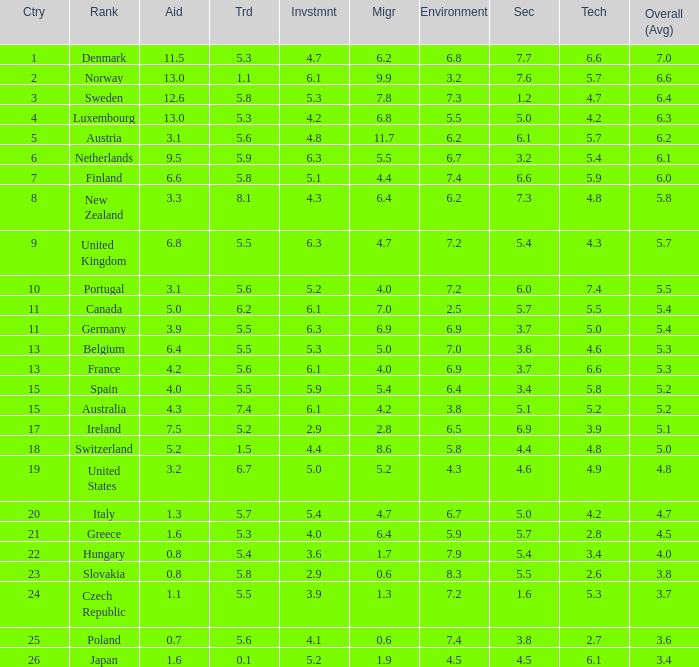What is the environment rating of the country with an overall average rating of 4.7? 6.7. 